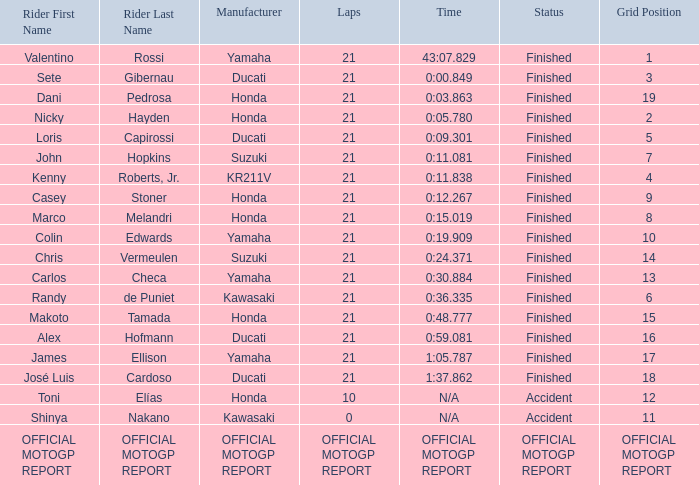When rider John Hopkins had 21 laps, what was the grid? 7.0. 